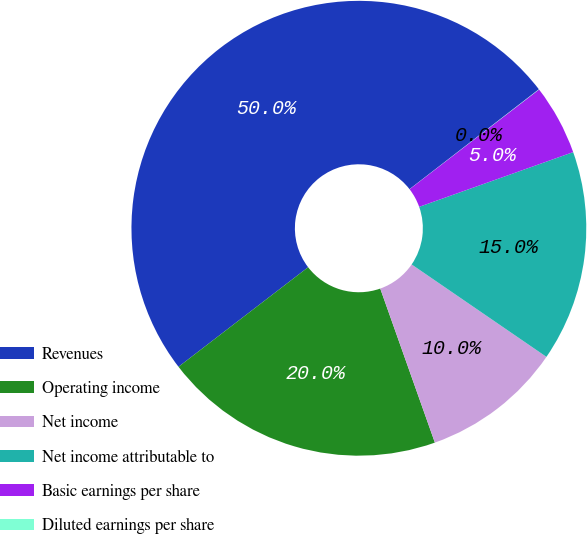Convert chart to OTSL. <chart><loc_0><loc_0><loc_500><loc_500><pie_chart><fcel>Revenues<fcel>Operating income<fcel>Net income<fcel>Net income attributable to<fcel>Basic earnings per share<fcel>Diluted earnings per share<nl><fcel>49.96%<fcel>20.0%<fcel>10.01%<fcel>15.0%<fcel>5.01%<fcel>0.02%<nl></chart> 